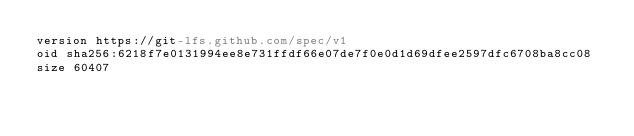<code> <loc_0><loc_0><loc_500><loc_500><_YAML_>version https://git-lfs.github.com/spec/v1
oid sha256:6218f7e0131994ee8e731ffdf66e07de7f0e0d1d69dfee2597dfc6708ba8cc08
size 60407
</code> 